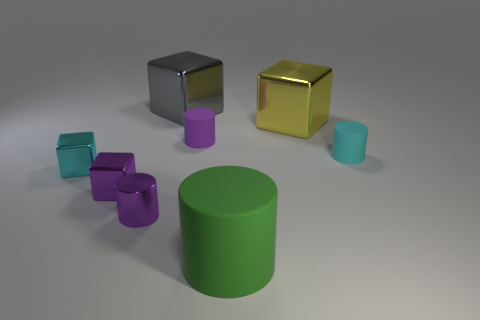Based on color and shape, what could the different objects represent in everyday life? The metallic cubes could represent anything from scaled architectural models to simple, modern art pieces. The purple and cyan cylinders might be stand-ins for products like cups or storage containers given their shapes and matte finish. The large green cylinder’s size and appearance could allow it to embody a simplistic representation of furniture or perhaps a structural column. 